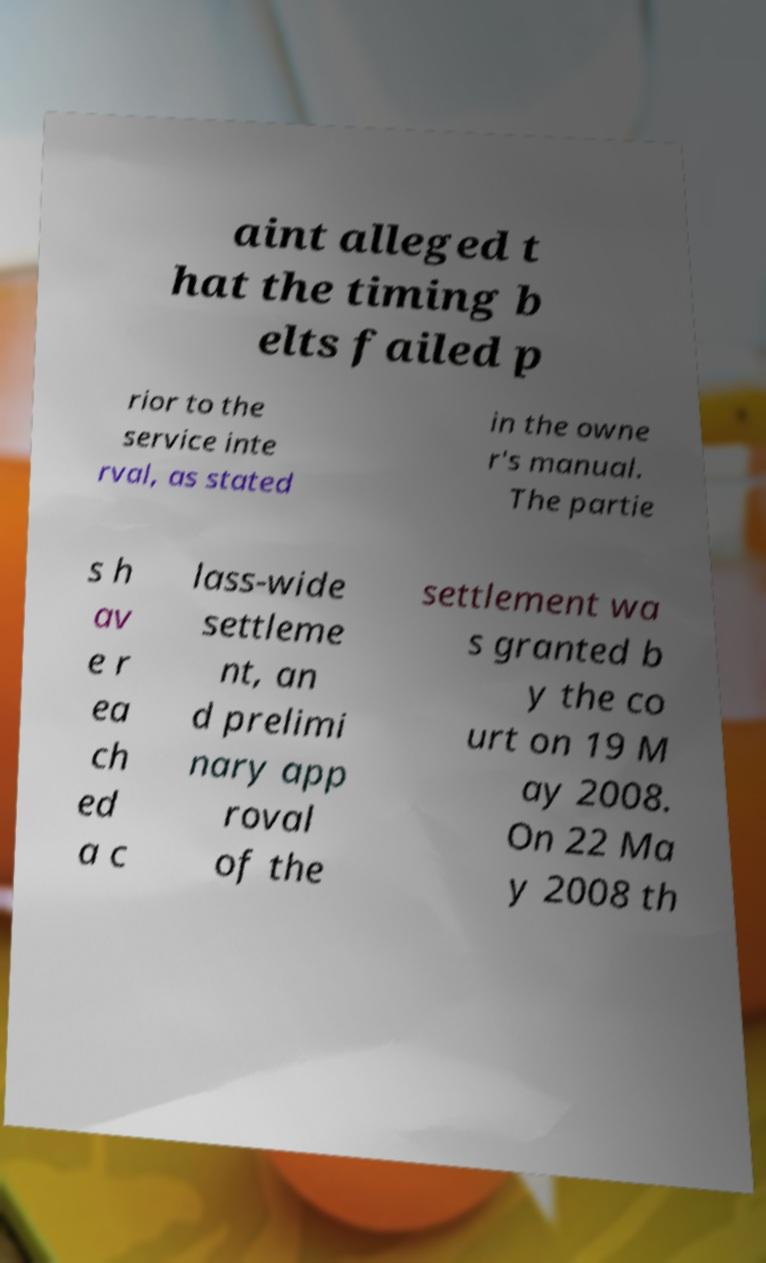There's text embedded in this image that I need extracted. Can you transcribe it verbatim? aint alleged t hat the timing b elts failed p rior to the service inte rval, as stated in the owne r's manual. The partie s h av e r ea ch ed a c lass-wide settleme nt, an d prelimi nary app roval of the settlement wa s granted b y the co urt on 19 M ay 2008. On 22 Ma y 2008 th 